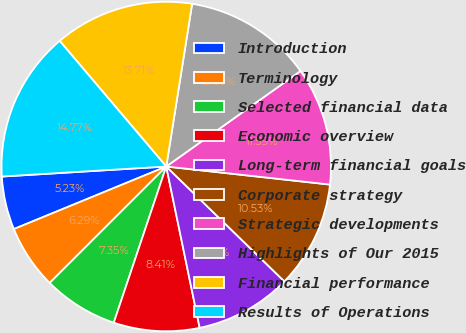<chart> <loc_0><loc_0><loc_500><loc_500><pie_chart><fcel>Introduction<fcel>Terminology<fcel>Selected financial data<fcel>Economic overview<fcel>Long-term financial goals<fcel>Corporate strategy<fcel>Strategic developments<fcel>Highlights of Our 2015<fcel>Financial performance<fcel>Results of Operations<nl><fcel>5.23%<fcel>6.29%<fcel>7.35%<fcel>8.41%<fcel>9.47%<fcel>10.53%<fcel>11.59%<fcel>12.65%<fcel>13.71%<fcel>14.77%<nl></chart> 